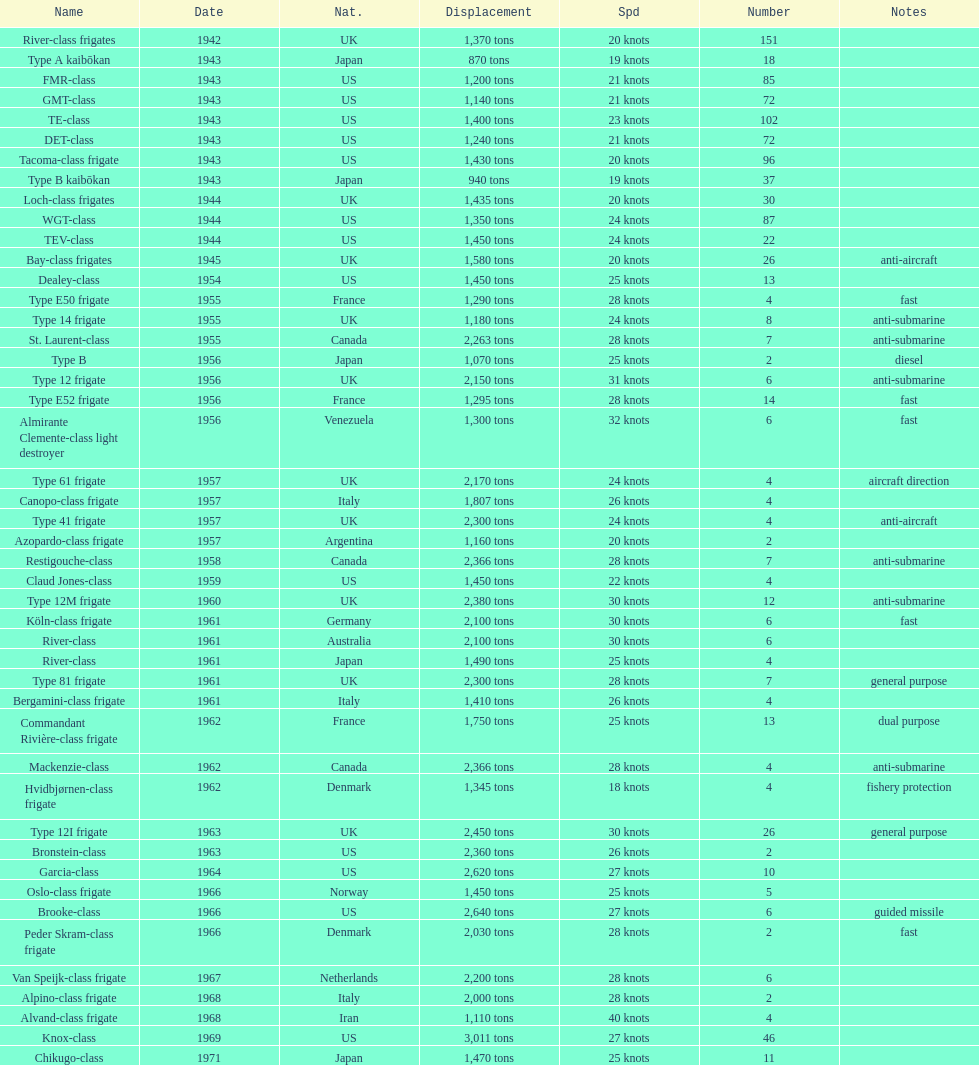What is the difference in speed for the gmt-class and the te-class? 2 knots. 